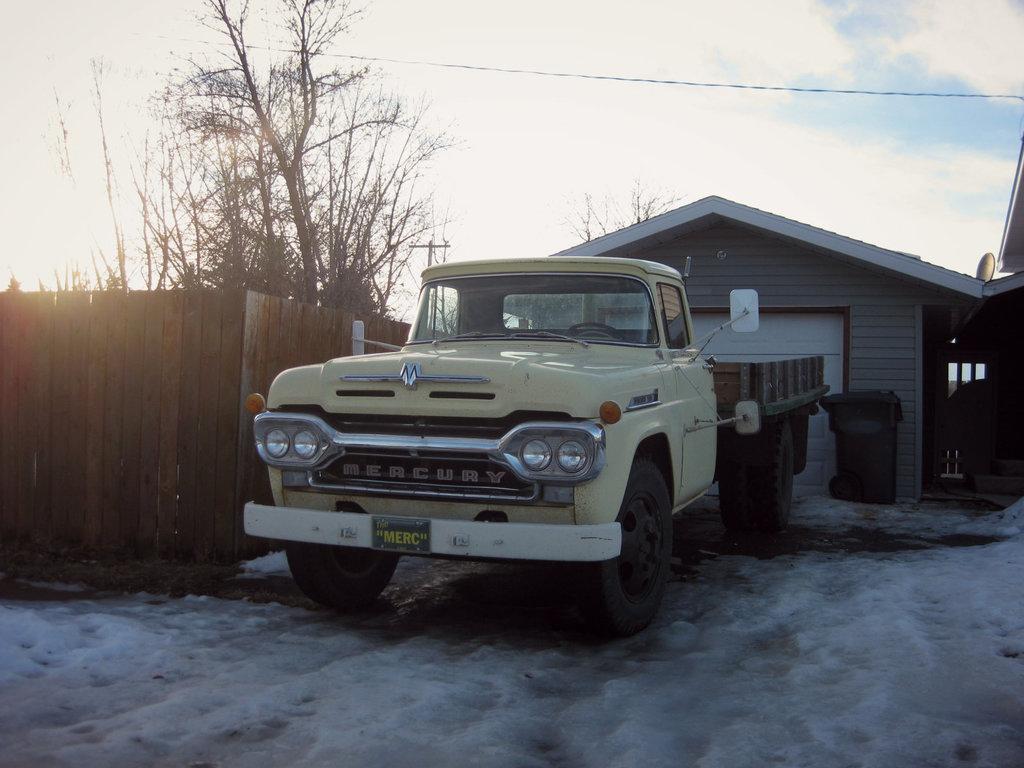What kind of truck is this?
Keep it short and to the point. Mercury. What is the liscense number?
Your answer should be very brief. Merc. 